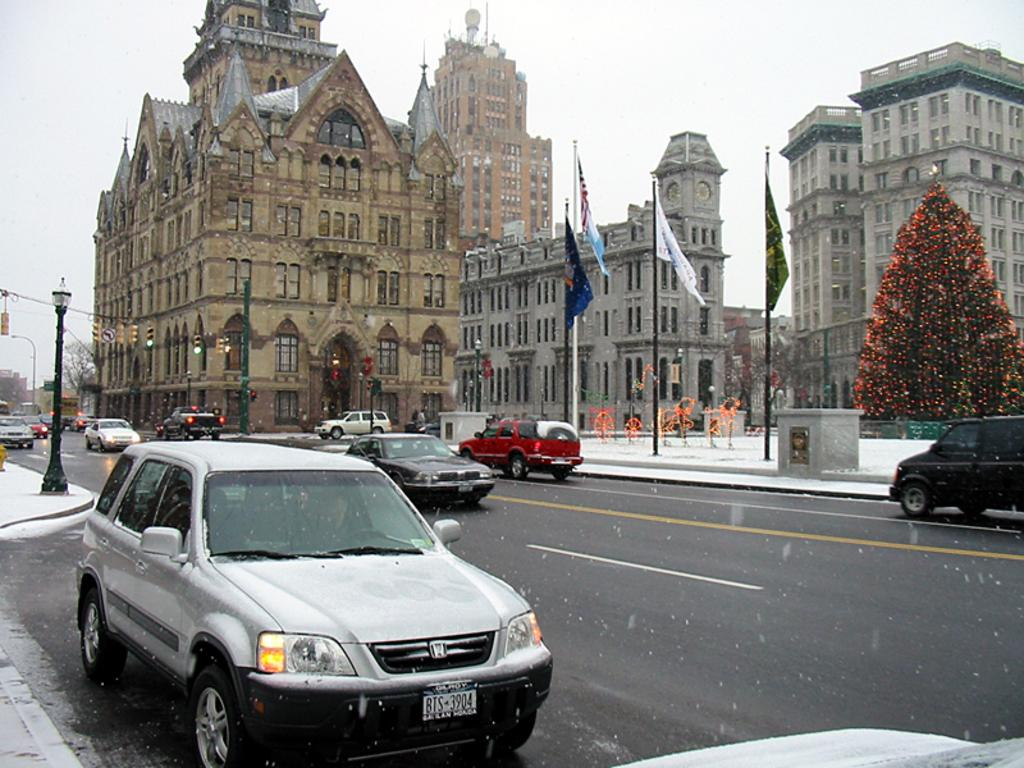What is happening in the foreground of the image? There are vehicles moving on the road in the foreground of the image. What can be seen in the background of the image? There is an Xmas tree, lights, flags, poles, buildings, and the sky visible in the background of the image. What type of sound can be heard coming from the pail in the image? There is no pail present in the image, so it is not possible to determine what, if any, sound might be heard. 